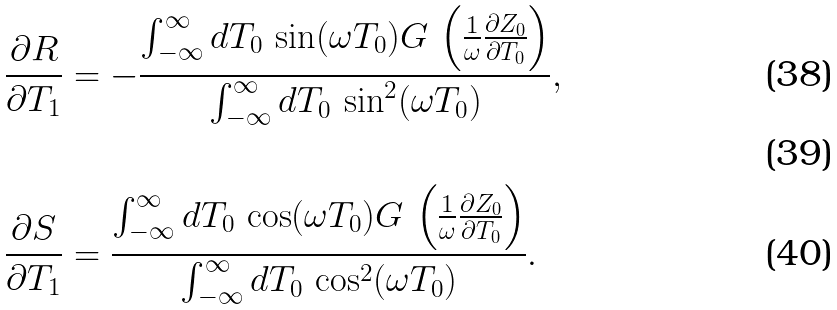<formula> <loc_0><loc_0><loc_500><loc_500>& \frac { \partial R } { \partial T _ { 1 } } = - \frac { \int _ { - \infty } ^ { \infty } { d T _ { 0 } \, \sin ( \omega T _ { 0 } ) G \, \left ( \frac { 1 } { \omega } \frac { \partial Z _ { 0 } } { \partial T _ { 0 } } \right ) } } { \int _ { - \infty } ^ { \infty } { d T _ { 0 } \, \sin ^ { 2 } ( \omega T _ { 0 } ) } } , \\ \\ & \frac { \partial S } { \partial T _ { 1 } } = \frac { \int _ { - \infty } ^ { \infty } { d T _ { 0 } \, \cos ( \omega T _ { 0 } ) G \, \left ( \frac { 1 } { \omega } \frac { \partial Z _ { 0 } } { \partial T _ { 0 } } \right ) } } { \int _ { - \infty } ^ { \infty } { d T _ { 0 } \, \cos ^ { 2 } ( \omega T _ { 0 } ) } } .</formula> 